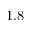<formula> <loc_0><loc_0><loc_500><loc_500>1 . 8</formula> 